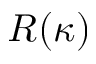Convert formula to latex. <formula><loc_0><loc_0><loc_500><loc_500>R ( \kappa )</formula> 